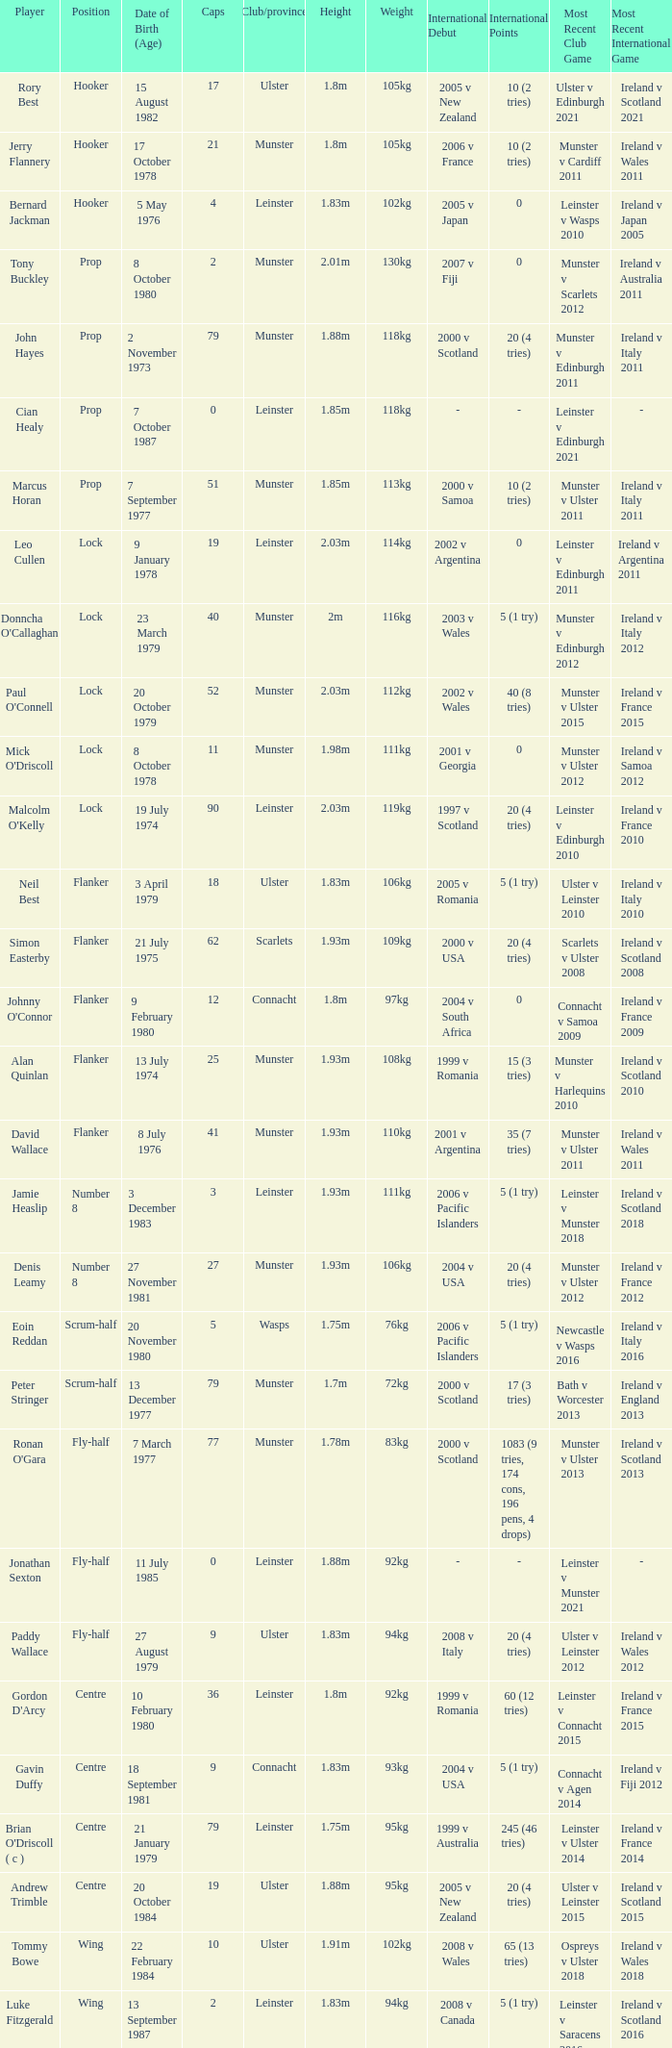How many Caps does the Club/province Munster, position of lock and Mick O'Driscoll have? 1.0. 